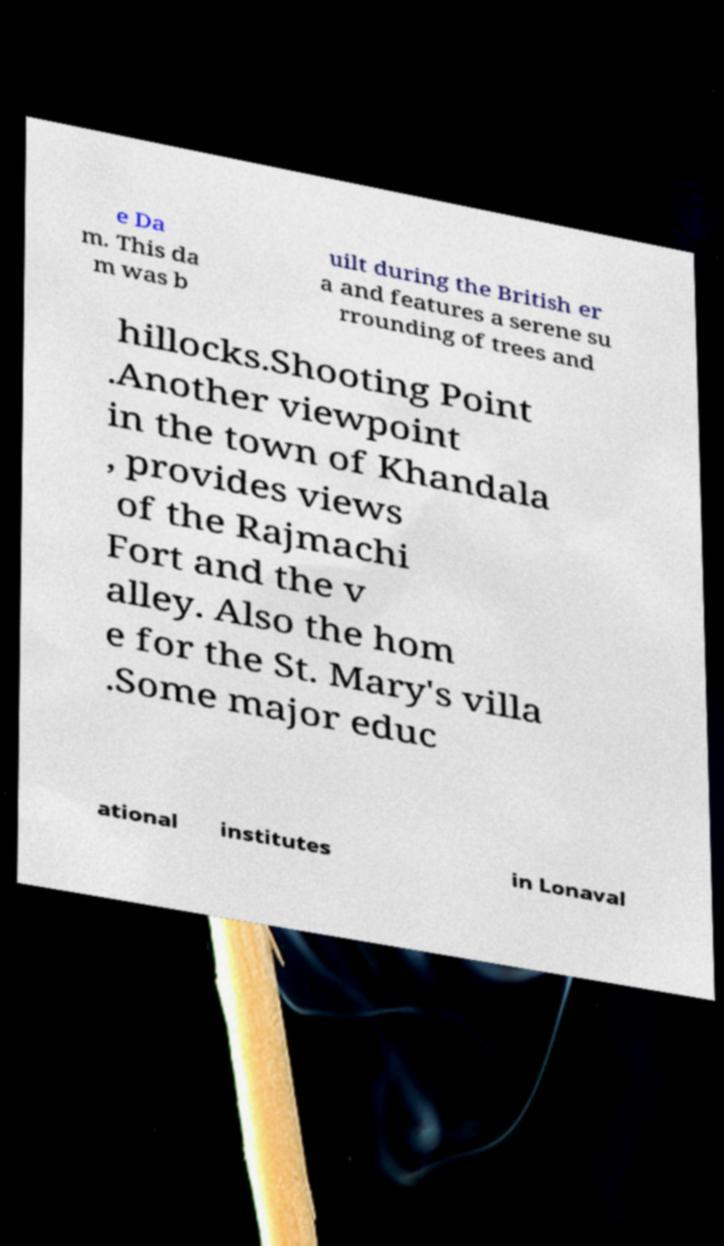Could you extract and type out the text from this image? e Da m. This da m was b uilt during the British er a and features a serene su rrounding of trees and hillocks.Shooting Point .Another viewpoint in the town of Khandala , provides views of the Rajmachi Fort and the v alley. Also the hom e for the St. Mary's villa .Some major educ ational institutes in Lonaval 